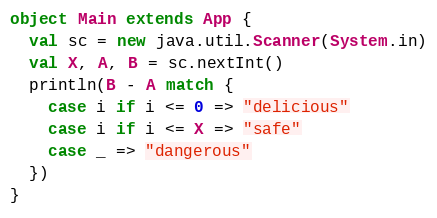Convert code to text. <code><loc_0><loc_0><loc_500><loc_500><_Scala_>object Main extends App {
  val sc = new java.util.Scanner(System.in)
  val X, A, B = sc.nextInt()
  println(B - A match {
    case i if i <= 0 => "delicious"
    case i if i <= X => "safe"
    case _ => "dangerous"
  })
}
</code> 